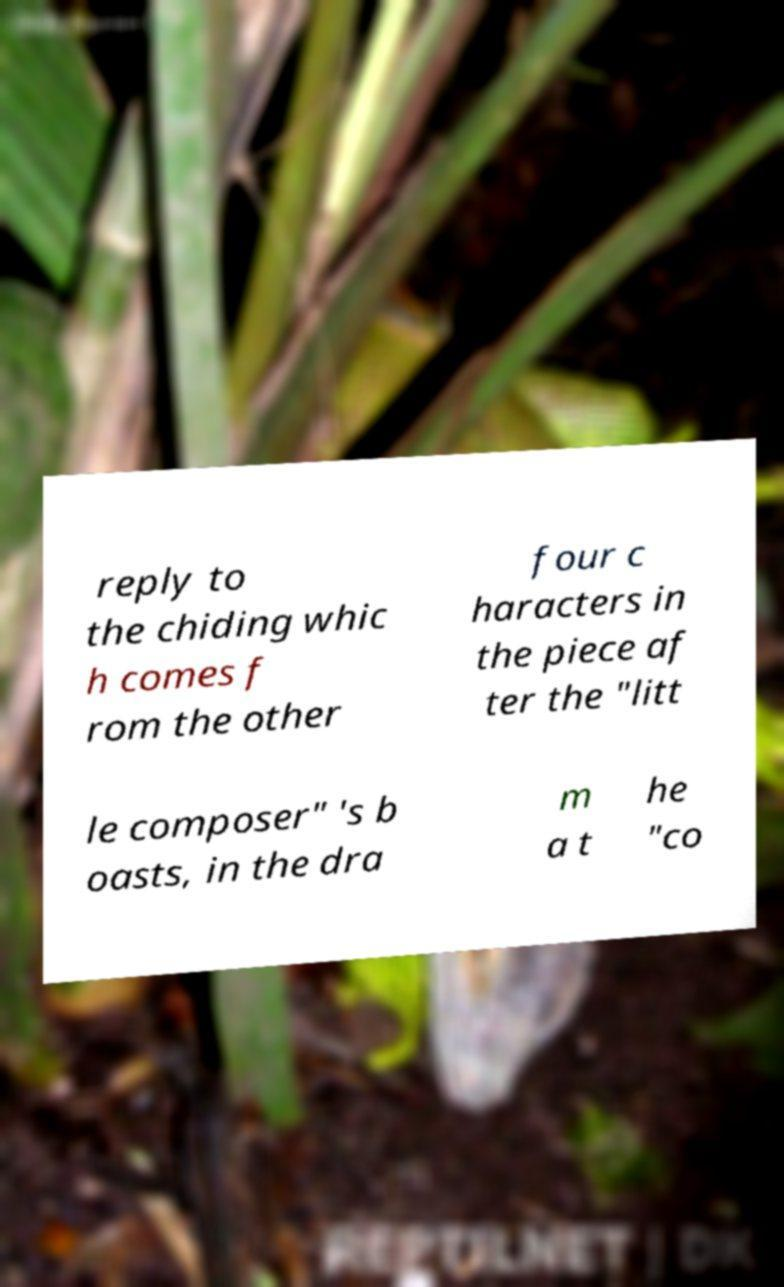Can you accurately transcribe the text from the provided image for me? reply to the chiding whic h comes f rom the other four c haracters in the piece af ter the "litt le composer" 's b oasts, in the dra m a t he "co 